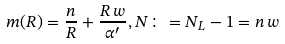<formula> <loc_0><loc_0><loc_500><loc_500>m ( R ) = \frac { n } { R } + \frac { R \, w } { \alpha ^ { \prime } } , N \colon = N _ { L } - 1 = n \, w</formula> 